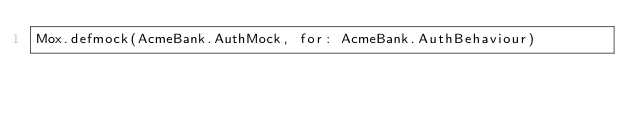Convert code to text. <code><loc_0><loc_0><loc_500><loc_500><_Elixir_>Mox.defmock(AcmeBank.AuthMock, for: AcmeBank.AuthBehaviour)
</code> 